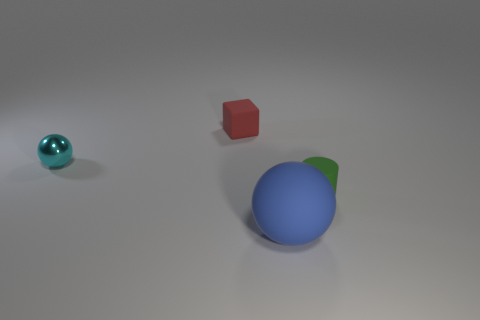How many cylinders are either big metallic things or matte things?
Your answer should be very brief. 1. Is the number of things behind the red thing less than the number of tiny red metallic balls?
Your answer should be compact. No. How many other things are there of the same material as the cyan object?
Offer a very short reply. 0. Do the matte sphere and the green rubber thing have the same size?
Your answer should be compact. No. How many objects are objects behind the big object or tiny shiny objects?
Ensure brevity in your answer.  3. What material is the sphere that is in front of the object that is left of the matte block?
Offer a very short reply. Rubber. Is there a big blue object that has the same shape as the green rubber object?
Offer a terse response. No. There is a red block; is its size the same as the ball behind the green cylinder?
Your answer should be very brief. Yes. How many objects are either small objects that are right of the red block or small rubber objects that are in front of the cube?
Offer a very short reply. 1. Are there more tiny blocks right of the tiny block than big rubber objects?
Keep it short and to the point. No. 